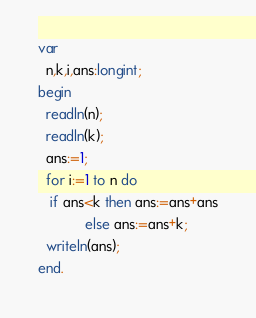Convert code to text. <code><loc_0><loc_0><loc_500><loc_500><_Pascal_>var
  n,k,i,ans:longint;
begin
  readln(n);
  readln(k);
  ans:=1;
  for i:=1 to n do
   if ans<k then ans:=ans+ans
            else ans:=ans+k;
  writeln(ans);
end.</code> 